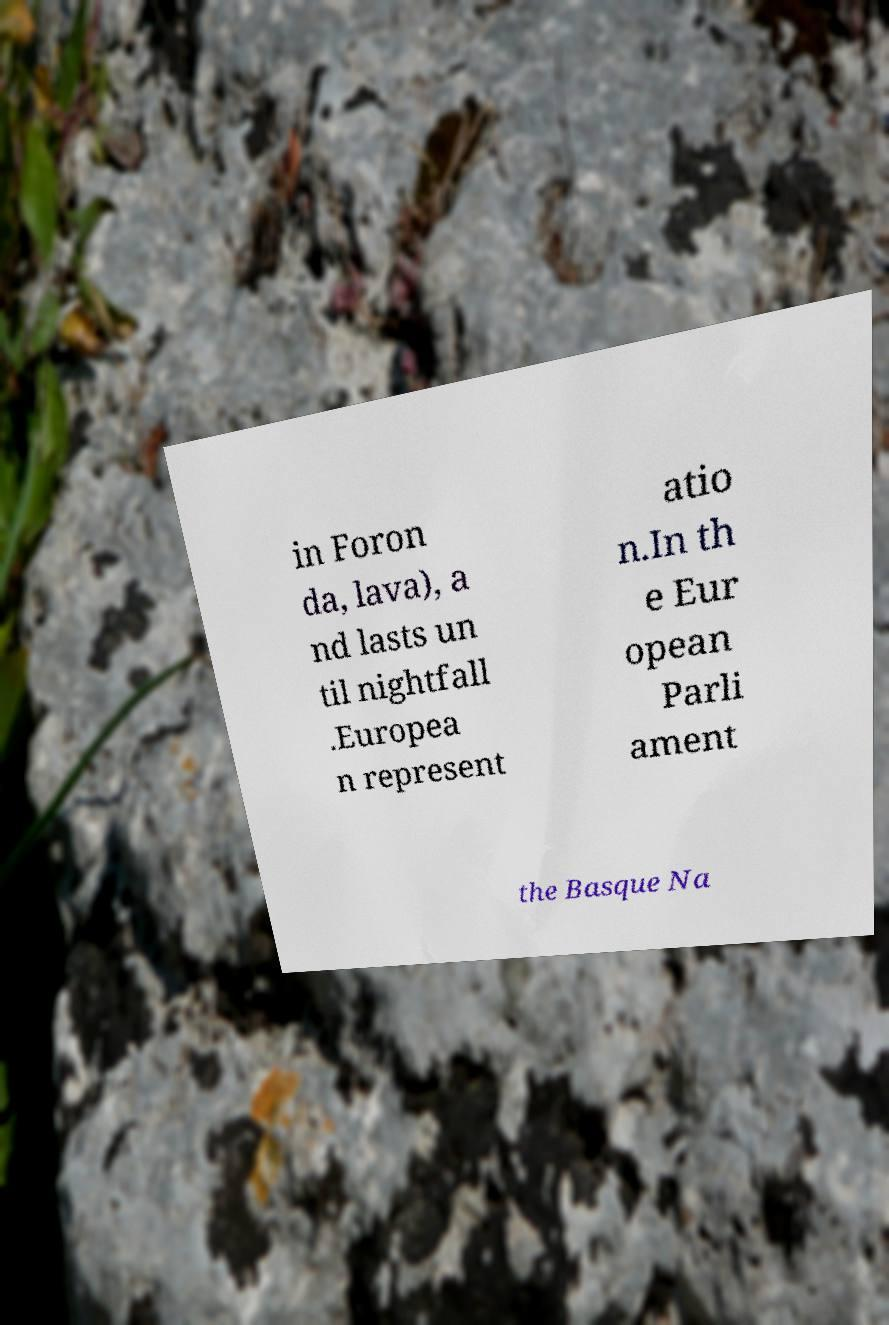Can you accurately transcribe the text from the provided image for me? in Foron da, lava), a nd lasts un til nightfall .Europea n represent atio n.In th e Eur opean Parli ament the Basque Na 